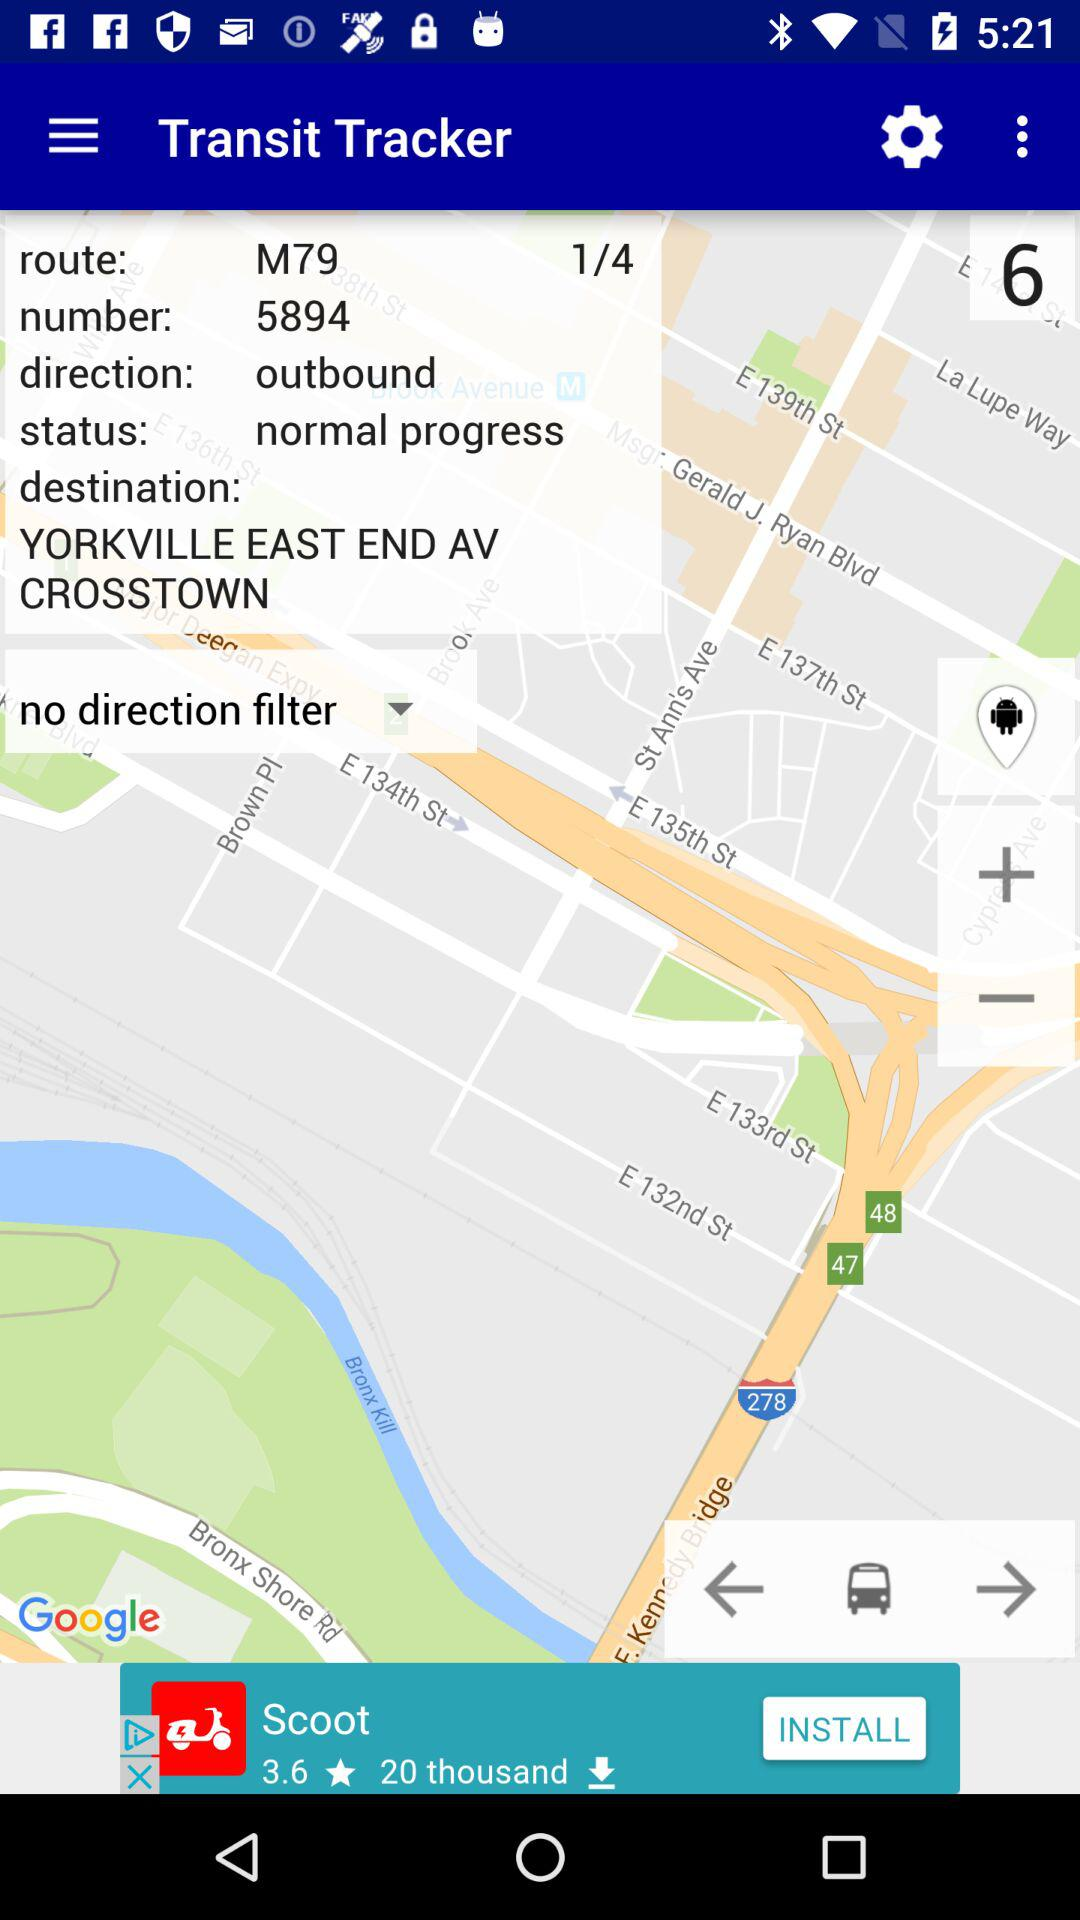What is the direction? The direction is outbound. 